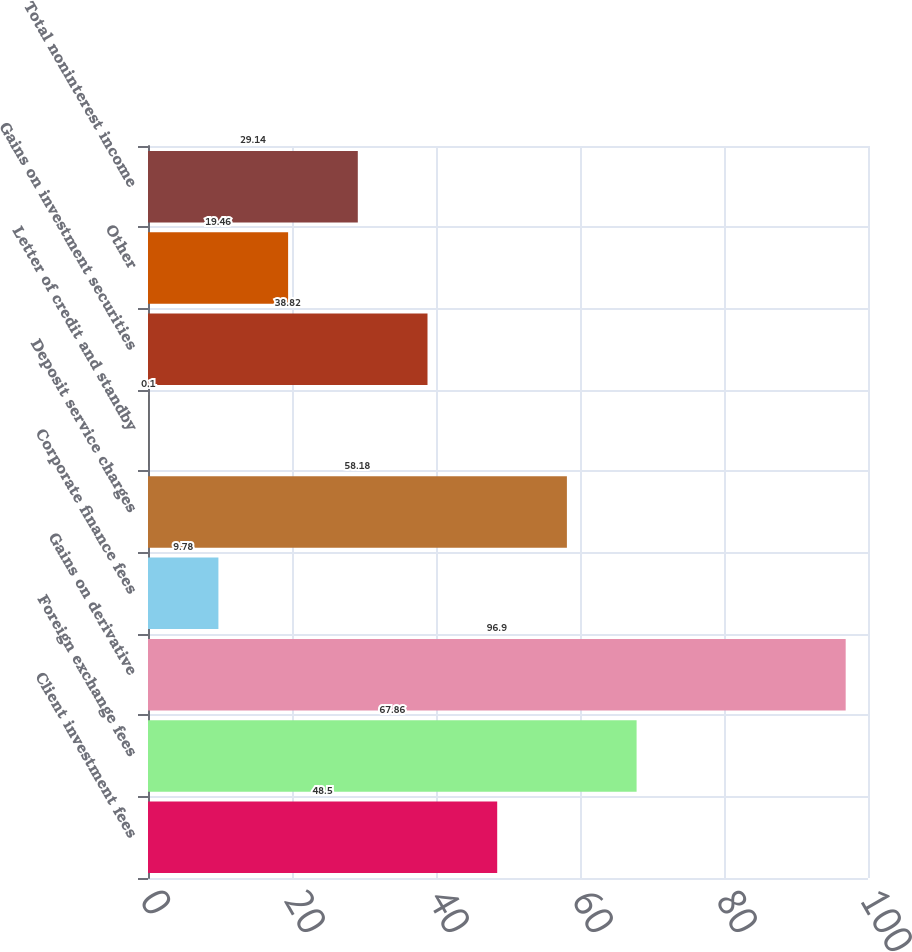Convert chart. <chart><loc_0><loc_0><loc_500><loc_500><bar_chart><fcel>Client investment fees<fcel>Foreign exchange fees<fcel>Gains on derivative<fcel>Corporate finance fees<fcel>Deposit service charges<fcel>Letter of credit and standby<fcel>Gains on investment securities<fcel>Other<fcel>Total noninterest income<nl><fcel>48.5<fcel>67.86<fcel>96.9<fcel>9.78<fcel>58.18<fcel>0.1<fcel>38.82<fcel>19.46<fcel>29.14<nl></chart> 